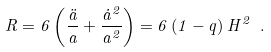<formula> <loc_0><loc_0><loc_500><loc_500>R = 6 \left ( \frac { \ddot { a } } { a } + \frac { \dot { a } ^ { 2 } } { a ^ { 2 } } \right ) = 6 \left ( 1 - q \right ) H ^ { 2 } \ .</formula> 